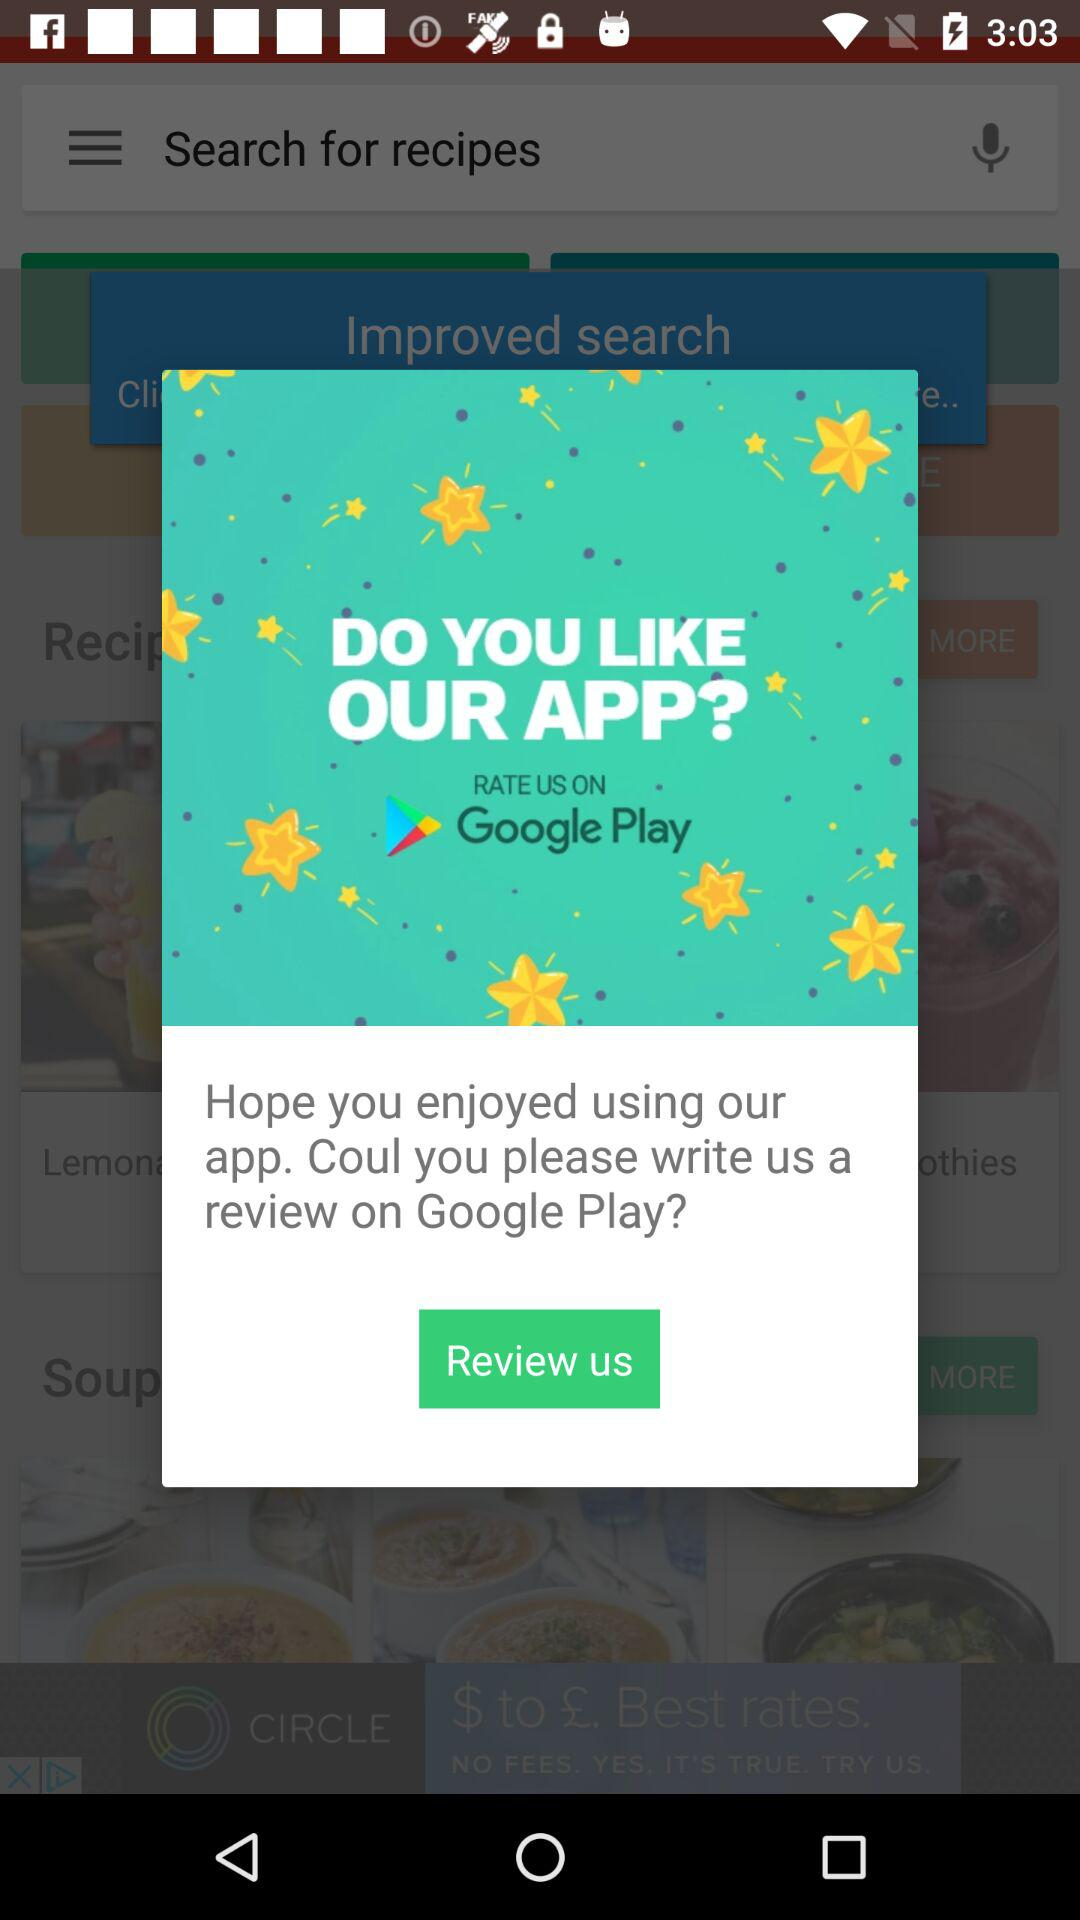Which recipes have been searched for?
When the provided information is insufficient, respond with <no answer>. <no answer> 